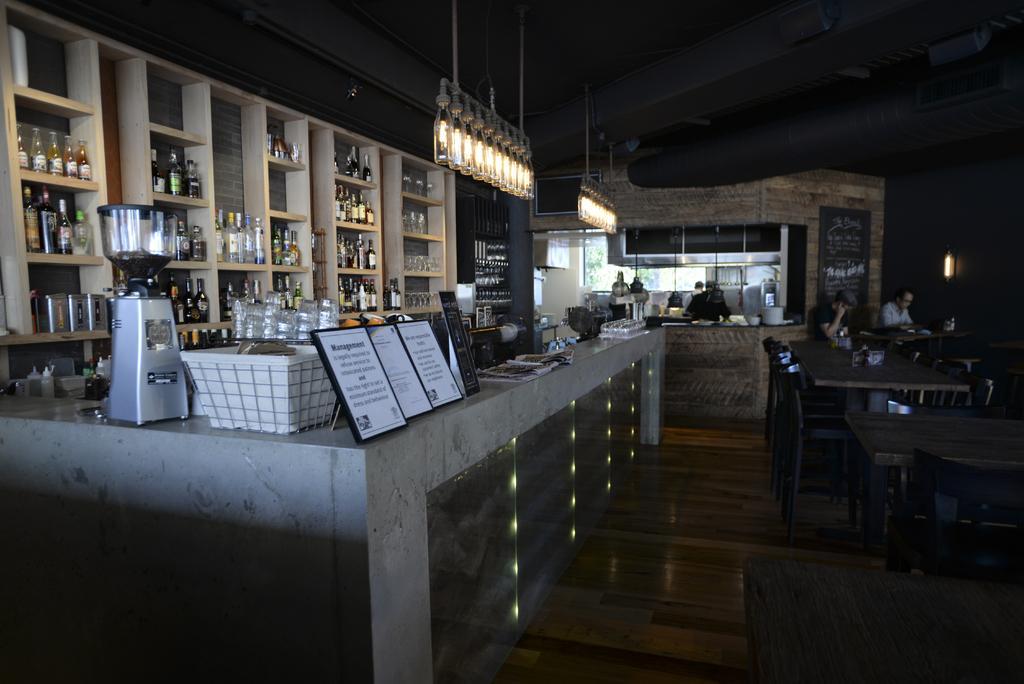Describe this image in one or two sentences. In this image we can see the inner view of a room which looks like a restaurant with tables and chairs. We can see a few people and there is a rack with objects like bottles, glasses and some other objects on the right side of the image and we can see some objects on the surface which looks like a countertop and there are some boards with text. 